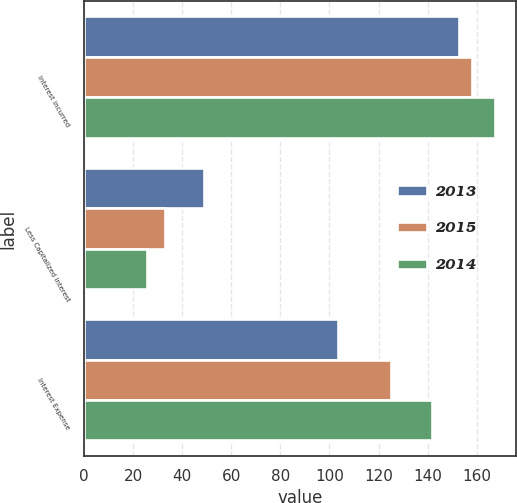Convert chart. <chart><loc_0><loc_0><loc_500><loc_500><stacked_bar_chart><ecel><fcel>Interest incurred<fcel>Less Capitalized interest<fcel>Interest Expense<nl><fcel>2013<fcel>152.6<fcel>49.1<fcel>103.5<nl><fcel>2015<fcel>158.1<fcel>33<fcel>125.1<nl><fcel>2014<fcel>167.6<fcel>25.8<fcel>141.8<nl></chart> 